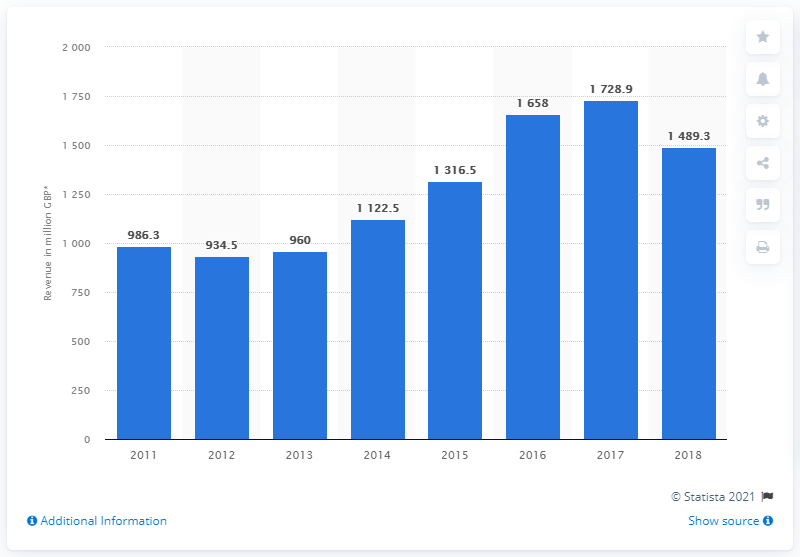Specify some key components in this picture. In 2012, Costain's revenue declined. In 2018, the total revenue of Costain plc was 1489.3 million pounds. 